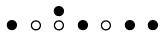Convert formula to latex. <formula><loc_0><loc_0><loc_500><loc_500>\begin{smallmatrix} & & \bullet \\ \bullet & \circ & \circ & \bullet & \circ & \bullet & \bullet & \\ \end{smallmatrix}</formula> 